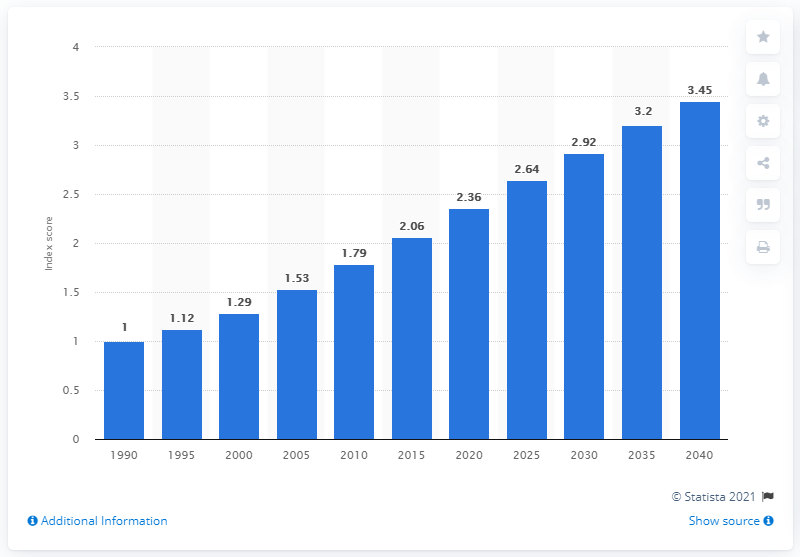Outline some significant characteristics in this image. The index score in 2000 was 1.29. 